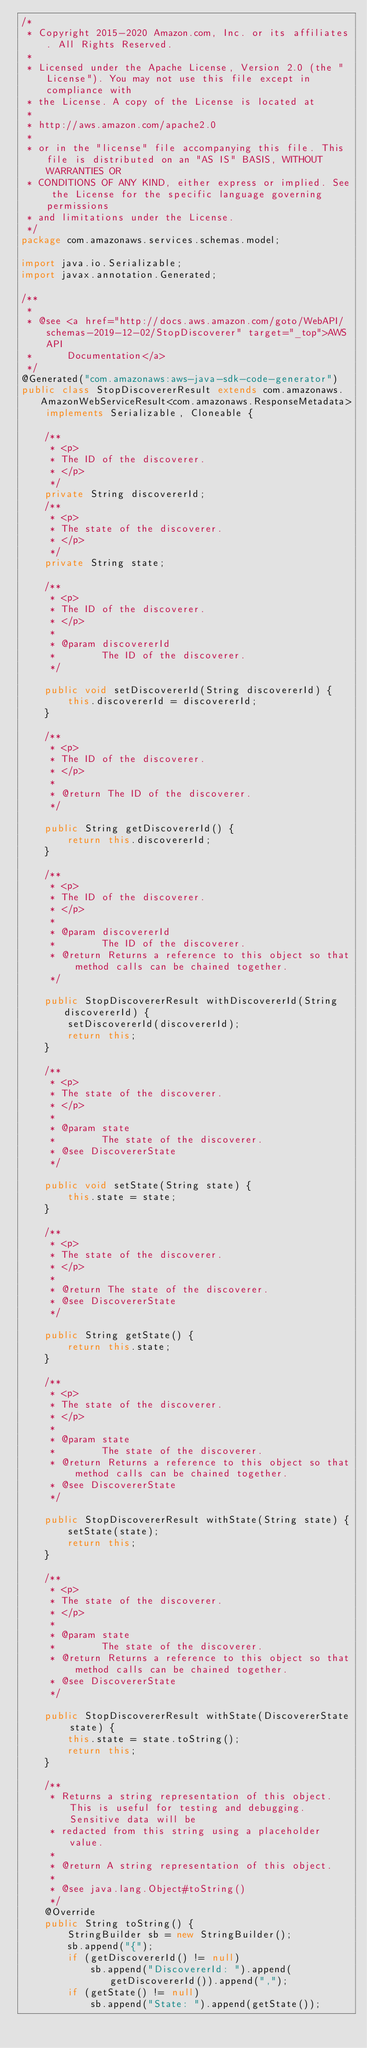<code> <loc_0><loc_0><loc_500><loc_500><_Java_>/*
 * Copyright 2015-2020 Amazon.com, Inc. or its affiliates. All Rights Reserved.
 * 
 * Licensed under the Apache License, Version 2.0 (the "License"). You may not use this file except in compliance with
 * the License. A copy of the License is located at
 * 
 * http://aws.amazon.com/apache2.0
 * 
 * or in the "license" file accompanying this file. This file is distributed on an "AS IS" BASIS, WITHOUT WARRANTIES OR
 * CONDITIONS OF ANY KIND, either express or implied. See the License for the specific language governing permissions
 * and limitations under the License.
 */
package com.amazonaws.services.schemas.model;

import java.io.Serializable;
import javax.annotation.Generated;

/**
 * 
 * @see <a href="http://docs.aws.amazon.com/goto/WebAPI/schemas-2019-12-02/StopDiscoverer" target="_top">AWS API
 *      Documentation</a>
 */
@Generated("com.amazonaws:aws-java-sdk-code-generator")
public class StopDiscovererResult extends com.amazonaws.AmazonWebServiceResult<com.amazonaws.ResponseMetadata> implements Serializable, Cloneable {

    /**
     * <p>
     * The ID of the discoverer.
     * </p>
     */
    private String discovererId;
    /**
     * <p>
     * The state of the discoverer.
     * </p>
     */
    private String state;

    /**
     * <p>
     * The ID of the discoverer.
     * </p>
     * 
     * @param discovererId
     *        The ID of the discoverer.
     */

    public void setDiscovererId(String discovererId) {
        this.discovererId = discovererId;
    }

    /**
     * <p>
     * The ID of the discoverer.
     * </p>
     * 
     * @return The ID of the discoverer.
     */

    public String getDiscovererId() {
        return this.discovererId;
    }

    /**
     * <p>
     * The ID of the discoverer.
     * </p>
     * 
     * @param discovererId
     *        The ID of the discoverer.
     * @return Returns a reference to this object so that method calls can be chained together.
     */

    public StopDiscovererResult withDiscovererId(String discovererId) {
        setDiscovererId(discovererId);
        return this;
    }

    /**
     * <p>
     * The state of the discoverer.
     * </p>
     * 
     * @param state
     *        The state of the discoverer.
     * @see DiscovererState
     */

    public void setState(String state) {
        this.state = state;
    }

    /**
     * <p>
     * The state of the discoverer.
     * </p>
     * 
     * @return The state of the discoverer.
     * @see DiscovererState
     */

    public String getState() {
        return this.state;
    }

    /**
     * <p>
     * The state of the discoverer.
     * </p>
     * 
     * @param state
     *        The state of the discoverer.
     * @return Returns a reference to this object so that method calls can be chained together.
     * @see DiscovererState
     */

    public StopDiscovererResult withState(String state) {
        setState(state);
        return this;
    }

    /**
     * <p>
     * The state of the discoverer.
     * </p>
     * 
     * @param state
     *        The state of the discoverer.
     * @return Returns a reference to this object so that method calls can be chained together.
     * @see DiscovererState
     */

    public StopDiscovererResult withState(DiscovererState state) {
        this.state = state.toString();
        return this;
    }

    /**
     * Returns a string representation of this object. This is useful for testing and debugging. Sensitive data will be
     * redacted from this string using a placeholder value.
     *
     * @return A string representation of this object.
     *
     * @see java.lang.Object#toString()
     */
    @Override
    public String toString() {
        StringBuilder sb = new StringBuilder();
        sb.append("{");
        if (getDiscovererId() != null)
            sb.append("DiscovererId: ").append(getDiscovererId()).append(",");
        if (getState() != null)
            sb.append("State: ").append(getState());</code> 